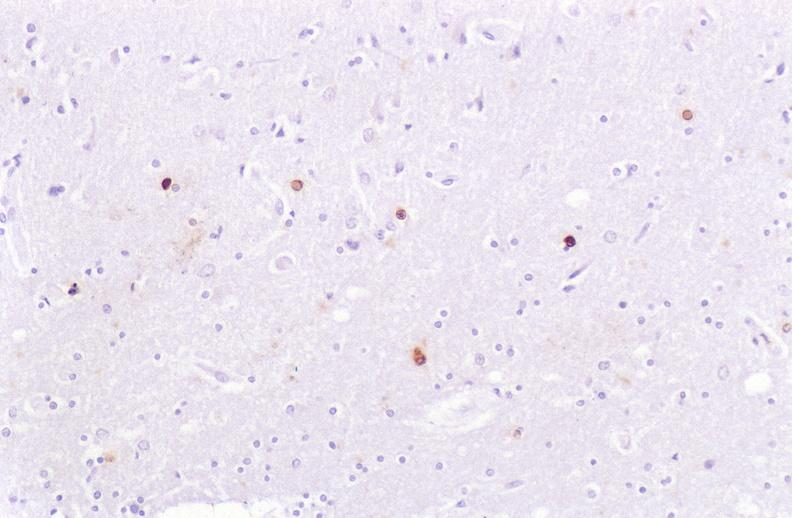what does this image show?
Answer the question using a single word or phrase. Brain 